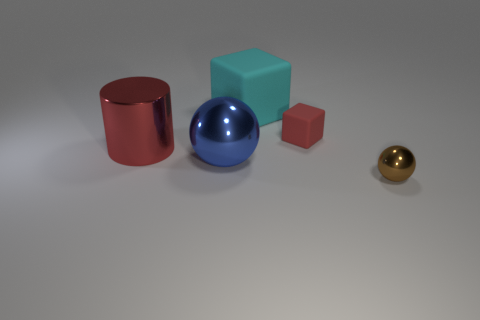There is a matte thing that is the same color as the large cylinder; what size is it?
Offer a very short reply. Small. The big shiny object that is in front of the metallic object behind the metallic ball that is left of the tiny brown metal sphere is what color?
Ensure brevity in your answer.  Blue. What is the shape of the red metallic object?
Give a very brief answer. Cylinder. There is a large rubber block; is its color the same as the sphere that is to the left of the tiny block?
Offer a very short reply. No. Are there an equal number of rubber cubes behind the red metallic thing and brown spheres?
Provide a succinct answer. No. How many red metal cubes have the same size as the red metallic cylinder?
Provide a succinct answer. 0. There is a large object that is the same color as the tiny matte thing; what shape is it?
Your answer should be very brief. Cylinder. Are any big purple rubber cylinders visible?
Provide a succinct answer. No. There is a red thing that is behind the red metallic cylinder; does it have the same shape as the large object in front of the red metal cylinder?
Your response must be concise. No. How many small things are blocks or blue metal things?
Offer a terse response. 1. 